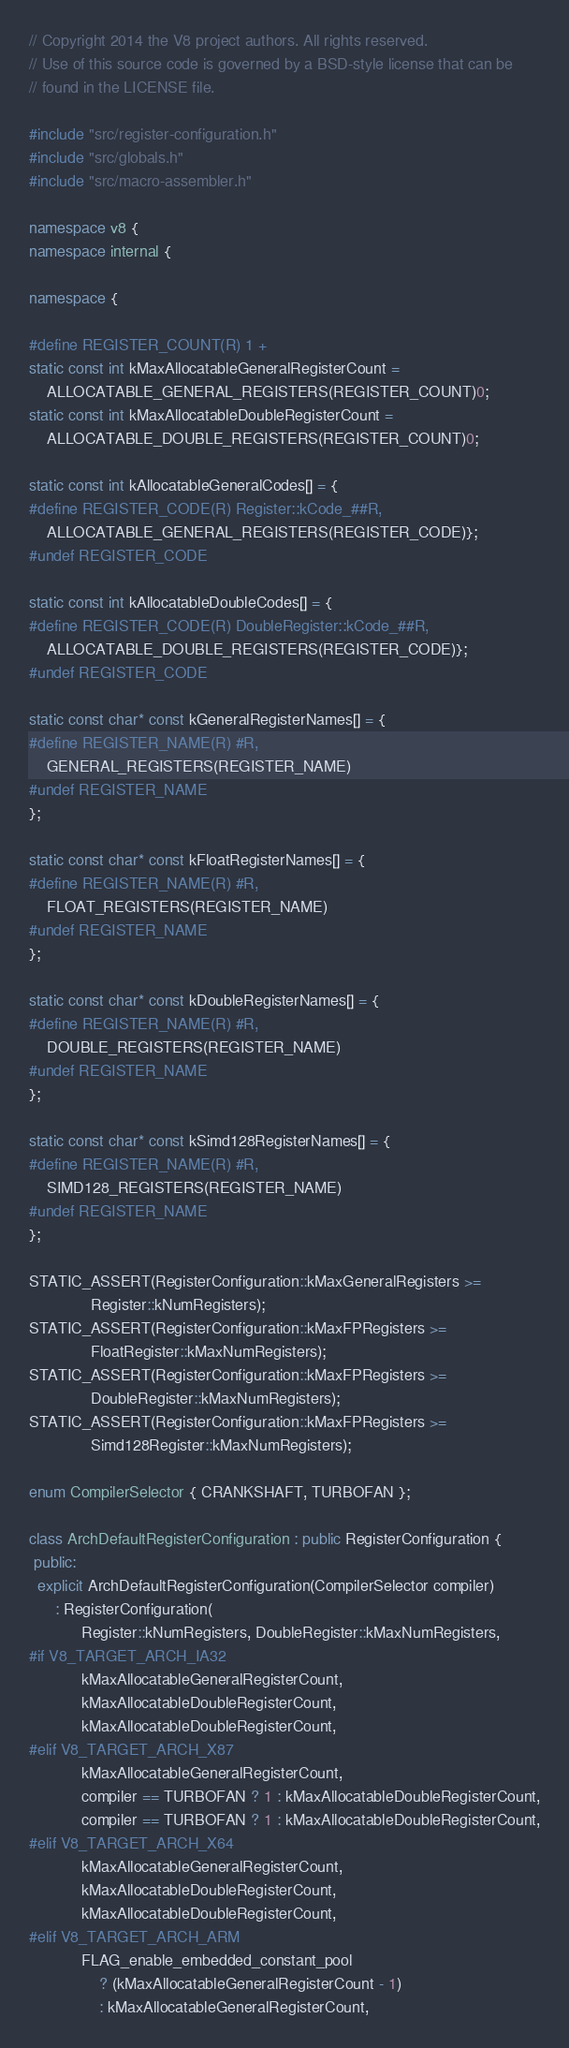Convert code to text. <code><loc_0><loc_0><loc_500><loc_500><_C++_>// Copyright 2014 the V8 project authors. All rights reserved.
// Use of this source code is governed by a BSD-style license that can be
// found in the LICENSE file.

#include "src/register-configuration.h"
#include "src/globals.h"
#include "src/macro-assembler.h"

namespace v8 {
namespace internal {

namespace {

#define REGISTER_COUNT(R) 1 +
static const int kMaxAllocatableGeneralRegisterCount =
    ALLOCATABLE_GENERAL_REGISTERS(REGISTER_COUNT)0;
static const int kMaxAllocatableDoubleRegisterCount =
    ALLOCATABLE_DOUBLE_REGISTERS(REGISTER_COUNT)0;

static const int kAllocatableGeneralCodes[] = {
#define REGISTER_CODE(R) Register::kCode_##R,
    ALLOCATABLE_GENERAL_REGISTERS(REGISTER_CODE)};
#undef REGISTER_CODE

static const int kAllocatableDoubleCodes[] = {
#define REGISTER_CODE(R) DoubleRegister::kCode_##R,
    ALLOCATABLE_DOUBLE_REGISTERS(REGISTER_CODE)};
#undef REGISTER_CODE

static const char* const kGeneralRegisterNames[] = {
#define REGISTER_NAME(R) #R,
    GENERAL_REGISTERS(REGISTER_NAME)
#undef REGISTER_NAME
};

static const char* const kFloatRegisterNames[] = {
#define REGISTER_NAME(R) #R,
    FLOAT_REGISTERS(REGISTER_NAME)
#undef REGISTER_NAME
};

static const char* const kDoubleRegisterNames[] = {
#define REGISTER_NAME(R) #R,
    DOUBLE_REGISTERS(REGISTER_NAME)
#undef REGISTER_NAME
};

static const char* const kSimd128RegisterNames[] = {
#define REGISTER_NAME(R) #R,
    SIMD128_REGISTERS(REGISTER_NAME)
#undef REGISTER_NAME
};

STATIC_ASSERT(RegisterConfiguration::kMaxGeneralRegisters >=
              Register::kNumRegisters);
STATIC_ASSERT(RegisterConfiguration::kMaxFPRegisters >=
              FloatRegister::kMaxNumRegisters);
STATIC_ASSERT(RegisterConfiguration::kMaxFPRegisters >=
              DoubleRegister::kMaxNumRegisters);
STATIC_ASSERT(RegisterConfiguration::kMaxFPRegisters >=
              Simd128Register::kMaxNumRegisters);

enum CompilerSelector { CRANKSHAFT, TURBOFAN };

class ArchDefaultRegisterConfiguration : public RegisterConfiguration {
 public:
  explicit ArchDefaultRegisterConfiguration(CompilerSelector compiler)
      : RegisterConfiguration(
            Register::kNumRegisters, DoubleRegister::kMaxNumRegisters,
#if V8_TARGET_ARCH_IA32
            kMaxAllocatableGeneralRegisterCount,
            kMaxAllocatableDoubleRegisterCount,
            kMaxAllocatableDoubleRegisterCount,
#elif V8_TARGET_ARCH_X87
            kMaxAllocatableGeneralRegisterCount,
            compiler == TURBOFAN ? 1 : kMaxAllocatableDoubleRegisterCount,
            compiler == TURBOFAN ? 1 : kMaxAllocatableDoubleRegisterCount,
#elif V8_TARGET_ARCH_X64
            kMaxAllocatableGeneralRegisterCount,
            kMaxAllocatableDoubleRegisterCount,
            kMaxAllocatableDoubleRegisterCount,
#elif V8_TARGET_ARCH_ARM
            FLAG_enable_embedded_constant_pool
                ? (kMaxAllocatableGeneralRegisterCount - 1)
                : kMaxAllocatableGeneralRegisterCount,</code> 